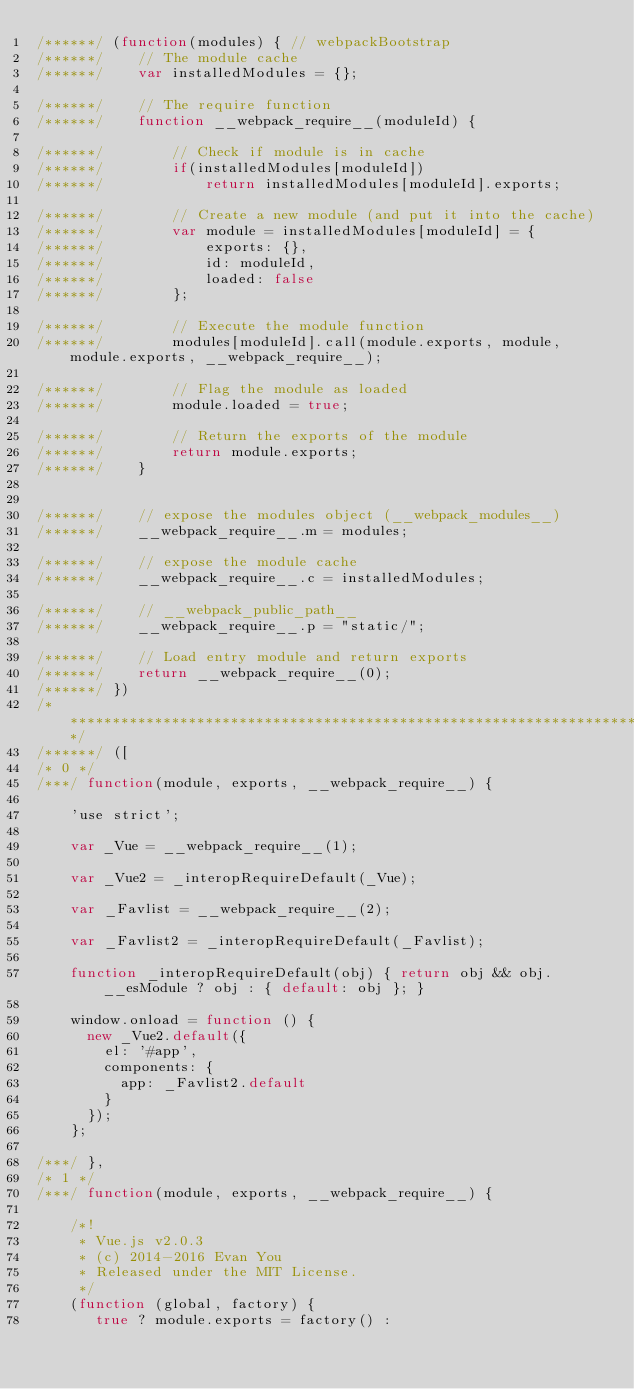Convert code to text. <code><loc_0><loc_0><loc_500><loc_500><_JavaScript_>/******/ (function(modules) { // webpackBootstrap
/******/ 	// The module cache
/******/ 	var installedModules = {};

/******/ 	// The require function
/******/ 	function __webpack_require__(moduleId) {

/******/ 		// Check if module is in cache
/******/ 		if(installedModules[moduleId])
/******/ 			return installedModules[moduleId].exports;

/******/ 		// Create a new module (and put it into the cache)
/******/ 		var module = installedModules[moduleId] = {
/******/ 			exports: {},
/******/ 			id: moduleId,
/******/ 			loaded: false
/******/ 		};

/******/ 		// Execute the module function
/******/ 		modules[moduleId].call(module.exports, module, module.exports, __webpack_require__);

/******/ 		// Flag the module as loaded
/******/ 		module.loaded = true;

/******/ 		// Return the exports of the module
/******/ 		return module.exports;
/******/ 	}


/******/ 	// expose the modules object (__webpack_modules__)
/******/ 	__webpack_require__.m = modules;

/******/ 	// expose the module cache
/******/ 	__webpack_require__.c = installedModules;

/******/ 	// __webpack_public_path__
/******/ 	__webpack_require__.p = "static/";

/******/ 	// Load entry module and return exports
/******/ 	return __webpack_require__(0);
/******/ })
/************************************************************************/
/******/ ([
/* 0 */
/***/ function(module, exports, __webpack_require__) {

	'use strict';

	var _Vue = __webpack_require__(1);

	var _Vue2 = _interopRequireDefault(_Vue);

	var _Favlist = __webpack_require__(2);

	var _Favlist2 = _interopRequireDefault(_Favlist);

	function _interopRequireDefault(obj) { return obj && obj.__esModule ? obj : { default: obj }; }

	window.onload = function () {
	  new _Vue2.default({
	    el: '#app',
	    components: {
	      app: _Favlist2.default
	    }
	  });
	};

/***/ },
/* 1 */
/***/ function(module, exports, __webpack_require__) {

	/*!
	 * Vue.js v2.0.3
	 * (c) 2014-2016 Evan You
	 * Released under the MIT License.
	 */
	(function (global, factory) {
	   true ? module.exports = factory() :</code> 